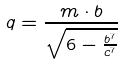<formula> <loc_0><loc_0><loc_500><loc_500>q = \frac { m \cdot b } { \sqrt { 6 - \frac { b ^ { 7 } } { c ^ { 7 } } } }</formula> 